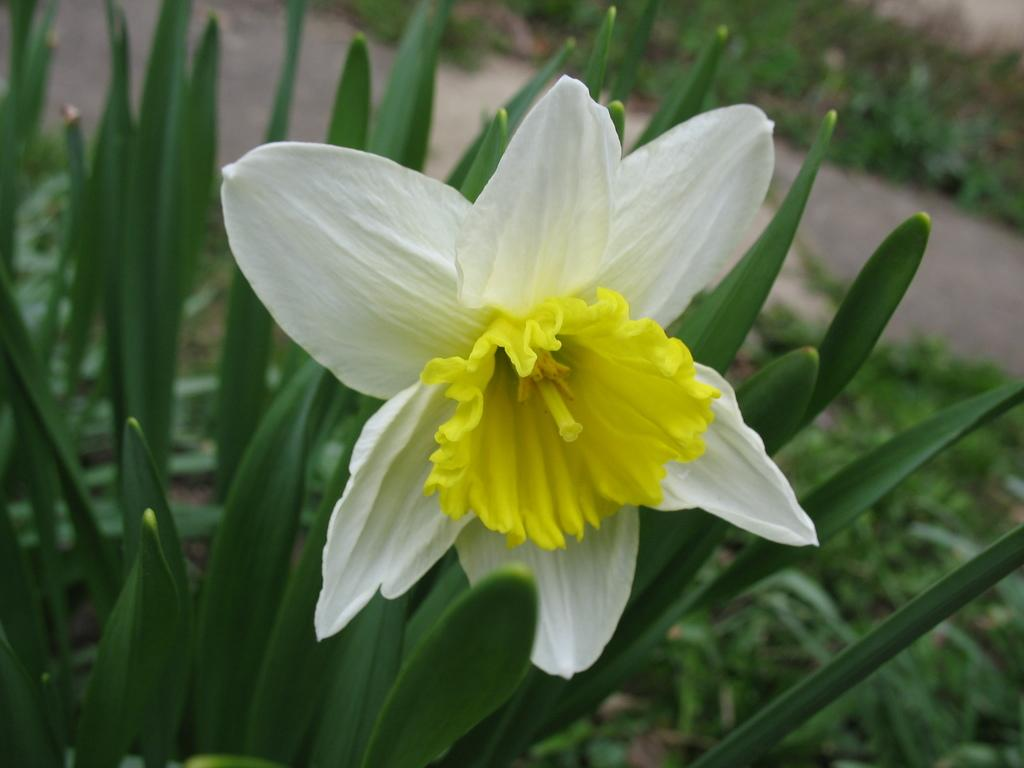What type of living organism can be seen in the image? There is a flower in the image. Are there any other plants visible in the image? Yes, there are plants in the image. What is the taste of the plastic in the image? There is no plastic present in the image, so it is not possible to determine its taste. 